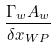<formula> <loc_0><loc_0><loc_500><loc_500>\frac { \Gamma _ { w } A _ { w } } { { \delta x } _ { W P } }</formula> 